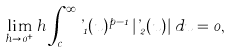Convert formula to latex. <formula><loc_0><loc_0><loc_500><loc_500>\lim _ { h \to 0 ^ { + } } h \int _ { c } ^ { \infty } \varphi _ { 1 } ( u ) ^ { p - 1 } \left | \varphi _ { 2 } ( u ) \right | \, d u = 0 ,</formula> 